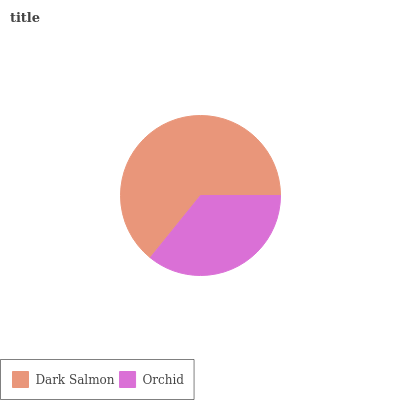Is Orchid the minimum?
Answer yes or no. Yes. Is Dark Salmon the maximum?
Answer yes or no. Yes. Is Orchid the maximum?
Answer yes or no. No. Is Dark Salmon greater than Orchid?
Answer yes or no. Yes. Is Orchid less than Dark Salmon?
Answer yes or no. Yes. Is Orchid greater than Dark Salmon?
Answer yes or no. No. Is Dark Salmon less than Orchid?
Answer yes or no. No. Is Dark Salmon the high median?
Answer yes or no. Yes. Is Orchid the low median?
Answer yes or no. Yes. Is Orchid the high median?
Answer yes or no. No. Is Dark Salmon the low median?
Answer yes or no. No. 